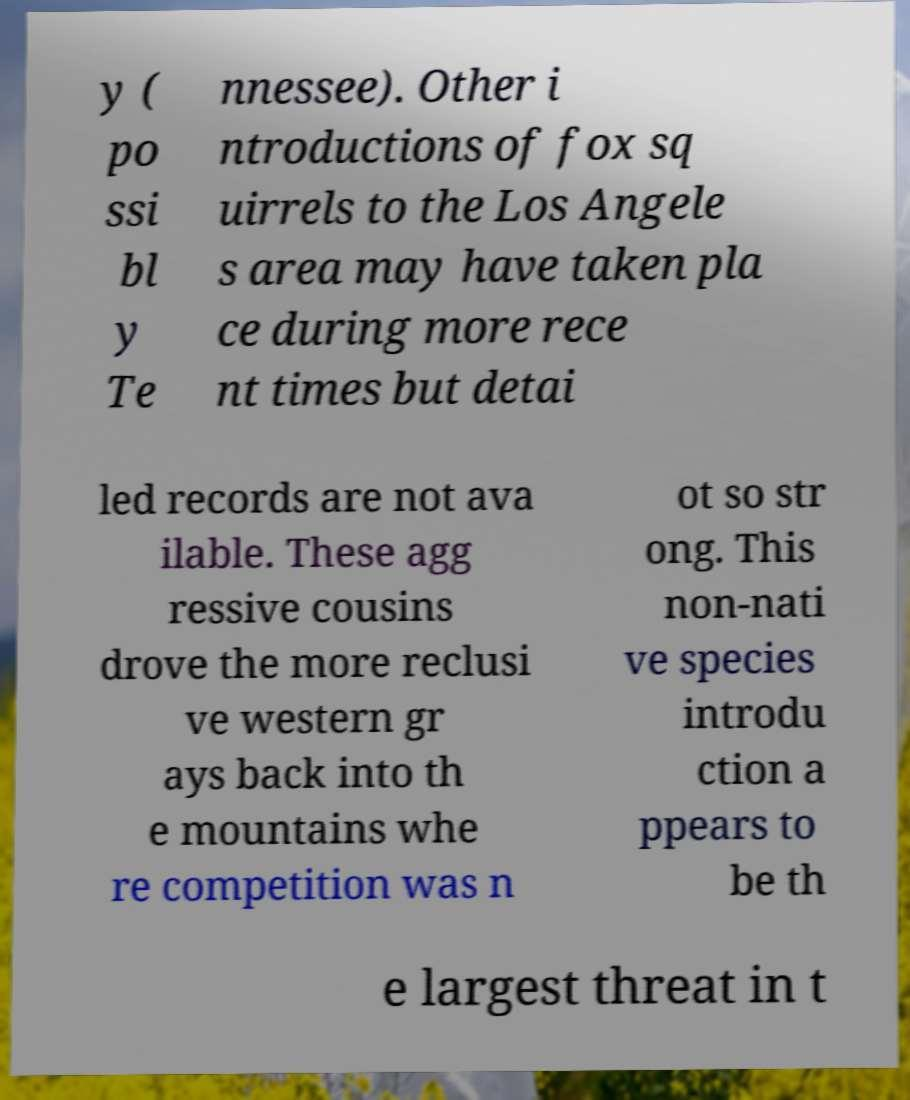Could you assist in decoding the text presented in this image and type it out clearly? y ( po ssi bl y Te nnessee). Other i ntroductions of fox sq uirrels to the Los Angele s area may have taken pla ce during more rece nt times but detai led records are not ava ilable. These agg ressive cousins drove the more reclusi ve western gr ays back into th e mountains whe re competition was n ot so str ong. This non-nati ve species introdu ction a ppears to be th e largest threat in t 